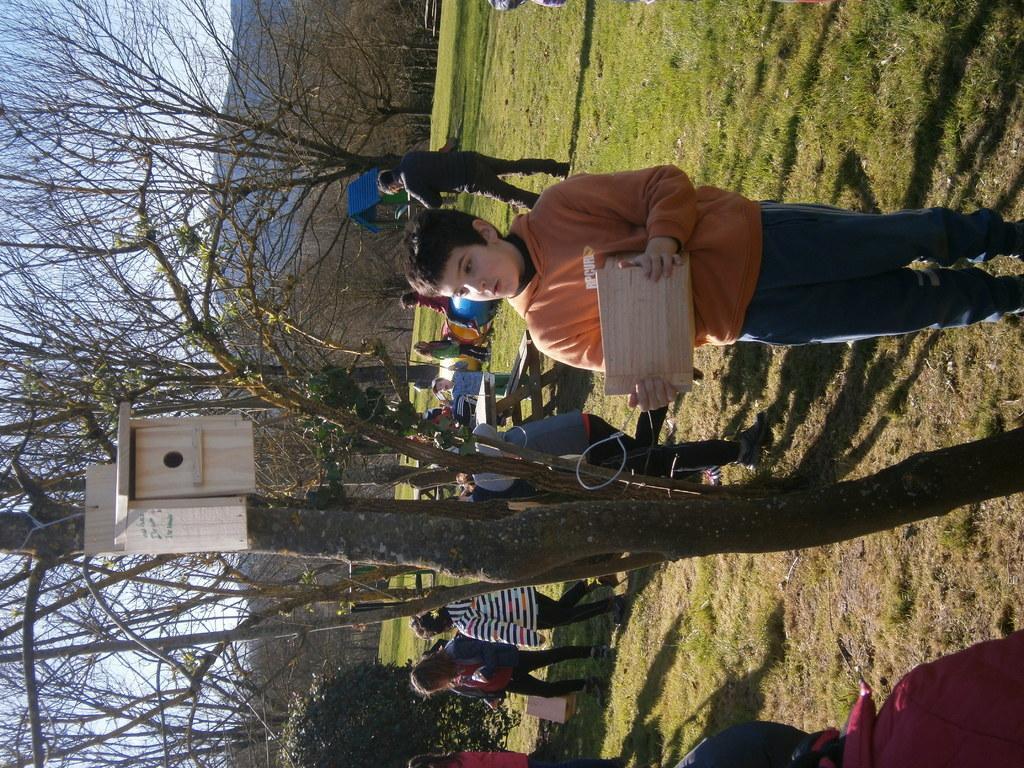How would you summarize this image in a sentence or two? In this picture we can see group of people, on the right side of the image we can find a boy, he is holding a wooden plank, in the background we can find few trees and hills. 